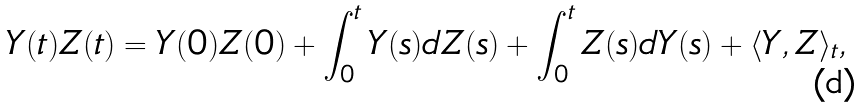Convert formula to latex. <formula><loc_0><loc_0><loc_500><loc_500>Y ( t ) Z ( t ) & = Y ( 0 ) Z ( 0 ) + \int _ { 0 } ^ { t } Y ( s ) d Z ( s ) + \int _ { 0 } ^ { t } Z ( s ) d Y ( s ) + \langle Y , Z \rangle _ { t } ,</formula> 